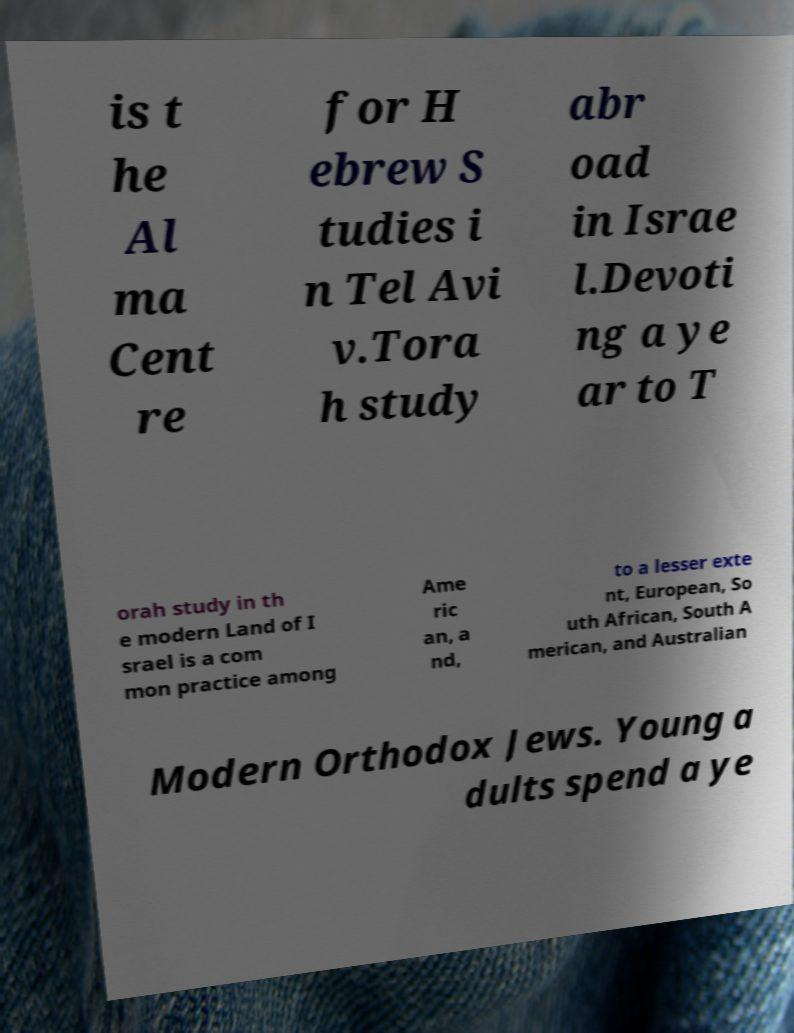For documentation purposes, I need the text within this image transcribed. Could you provide that? is t he Al ma Cent re for H ebrew S tudies i n Tel Avi v.Tora h study abr oad in Israe l.Devoti ng a ye ar to T orah study in th e modern Land of I srael is a com mon practice among Ame ric an, a nd, to a lesser exte nt, European, So uth African, South A merican, and Australian Modern Orthodox Jews. Young a dults spend a ye 